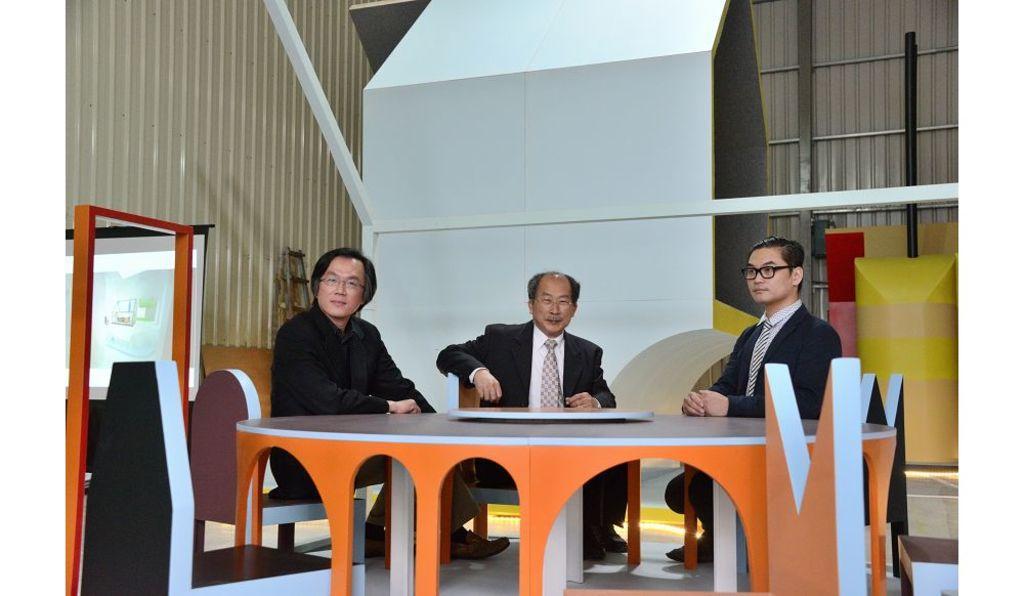How would you summarize this image in a sentence or two? There are people sitting in front of a table in the foreground area of the image, there is a door and other objects in the background. 